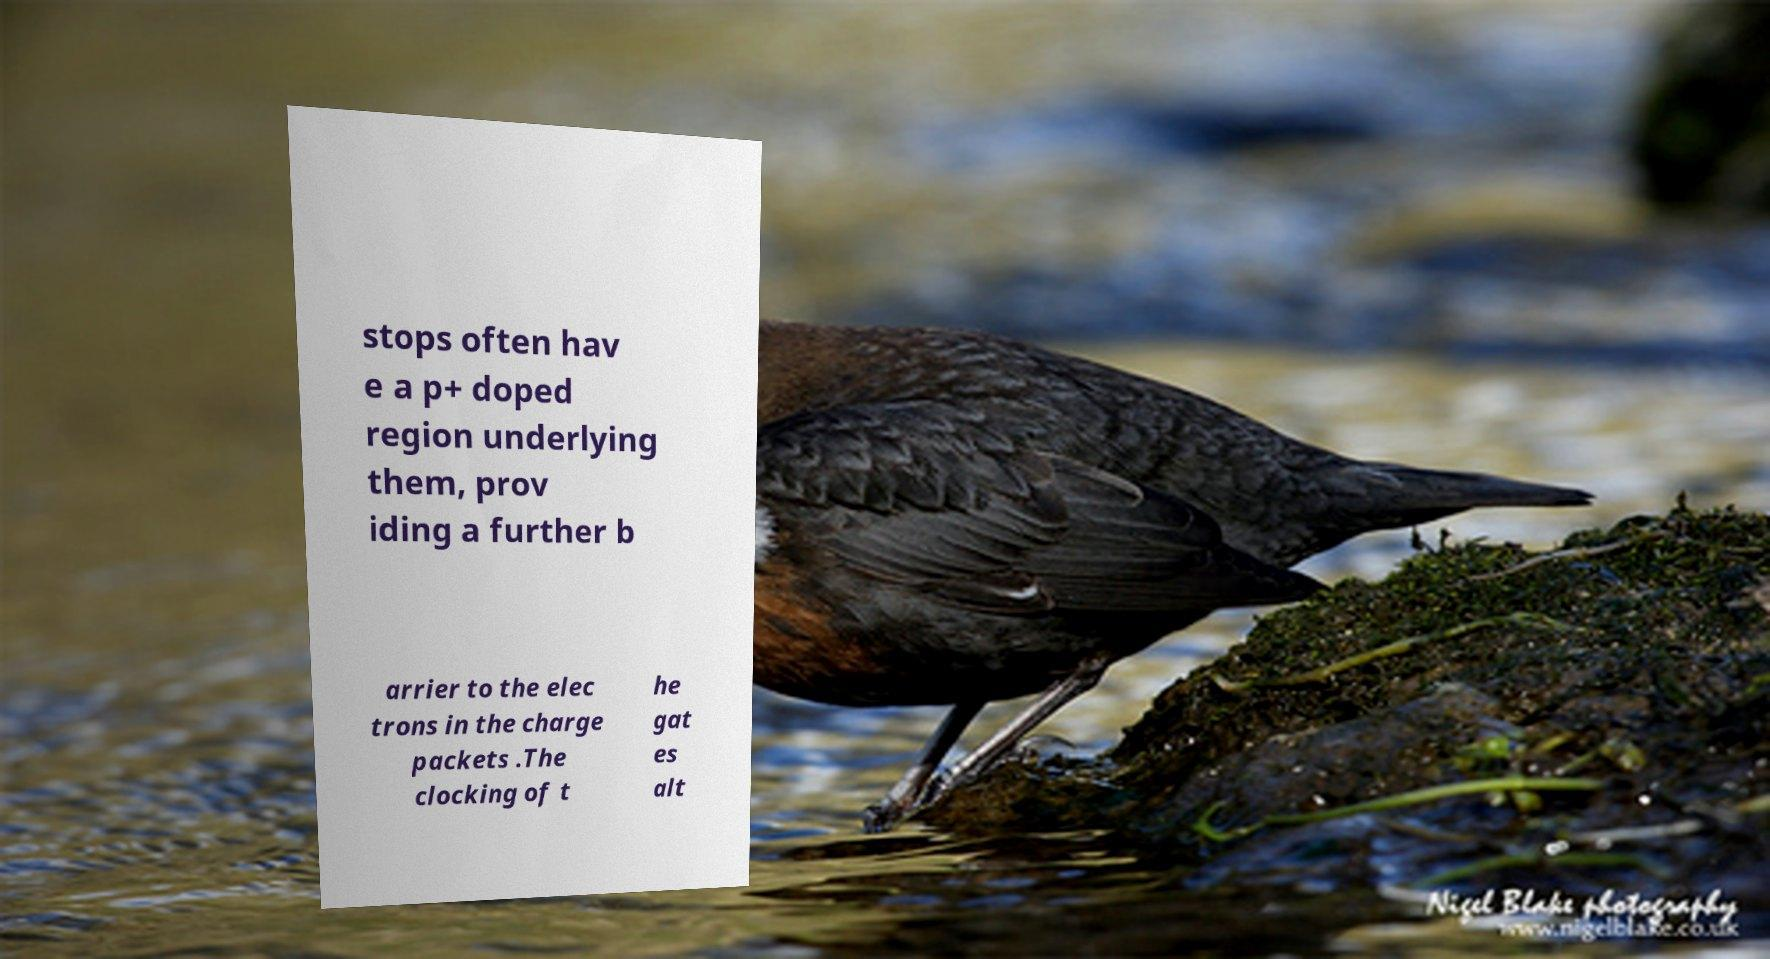Can you read and provide the text displayed in the image?This photo seems to have some interesting text. Can you extract and type it out for me? stops often hav e a p+ doped region underlying them, prov iding a further b arrier to the elec trons in the charge packets .The clocking of t he gat es alt 